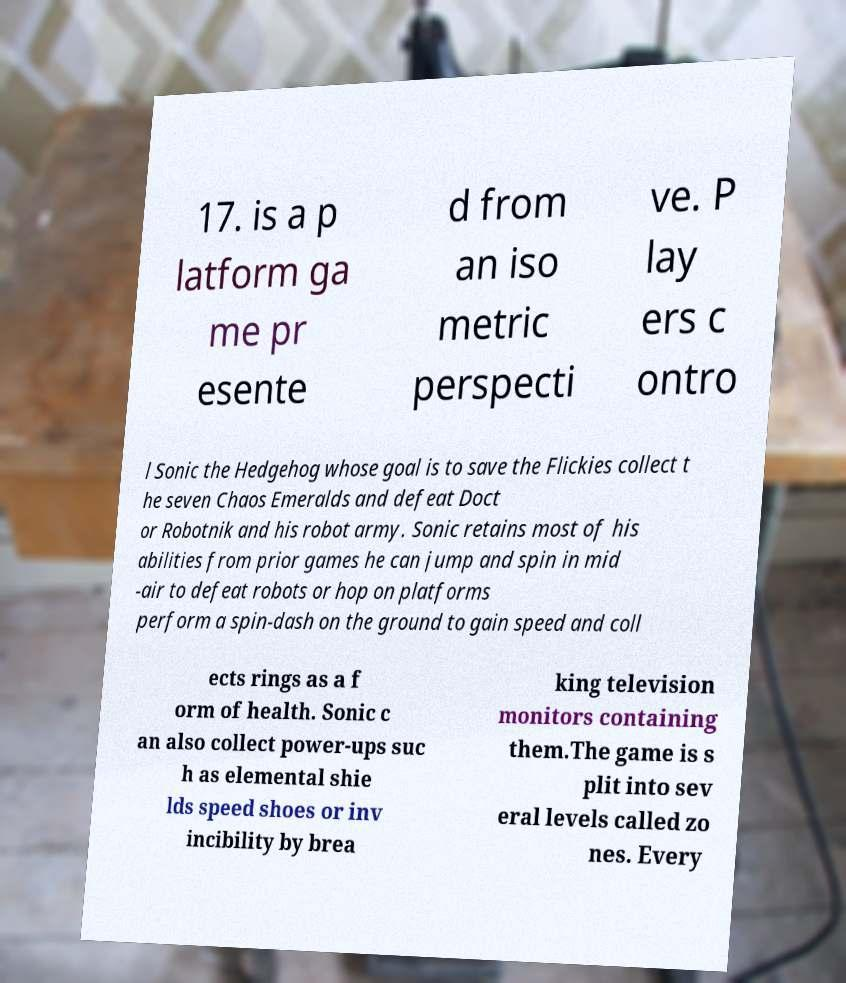Can you read and provide the text displayed in the image?This photo seems to have some interesting text. Can you extract and type it out for me? 17. is a p latform ga me pr esente d from an iso metric perspecti ve. P lay ers c ontro l Sonic the Hedgehog whose goal is to save the Flickies collect t he seven Chaos Emeralds and defeat Doct or Robotnik and his robot army. Sonic retains most of his abilities from prior games he can jump and spin in mid -air to defeat robots or hop on platforms perform a spin-dash on the ground to gain speed and coll ects rings as a f orm of health. Sonic c an also collect power-ups suc h as elemental shie lds speed shoes or inv incibility by brea king television monitors containing them.The game is s plit into sev eral levels called zo nes. Every 